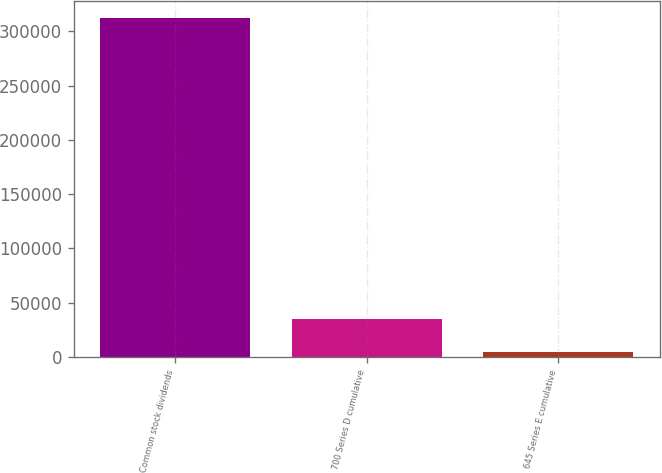Convert chart to OTSL. <chart><loc_0><loc_0><loc_500><loc_500><bar_chart><fcel>Common stock dividends<fcel>700 Series D cumulative<fcel>645 Series E cumulative<nl><fcel>312131<fcel>34986.8<fcel>4193<nl></chart> 